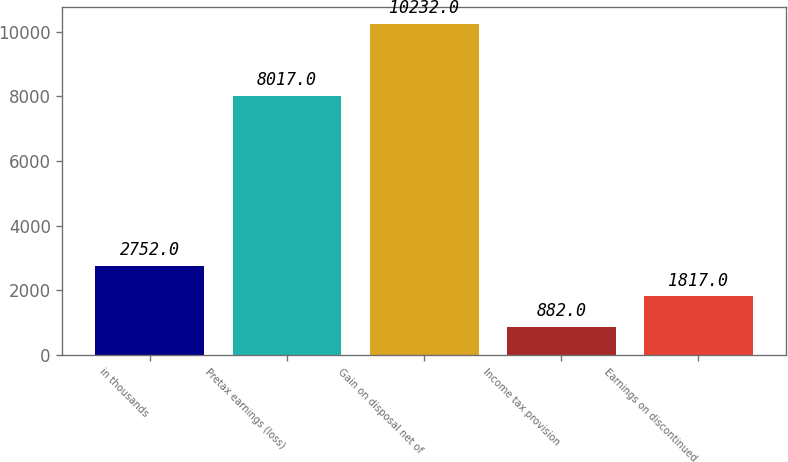<chart> <loc_0><loc_0><loc_500><loc_500><bar_chart><fcel>in thousands<fcel>Pretax earnings (loss)<fcel>Gain on disposal net of<fcel>Income tax provision<fcel>Earnings on discontinued<nl><fcel>2752<fcel>8017<fcel>10232<fcel>882<fcel>1817<nl></chart> 